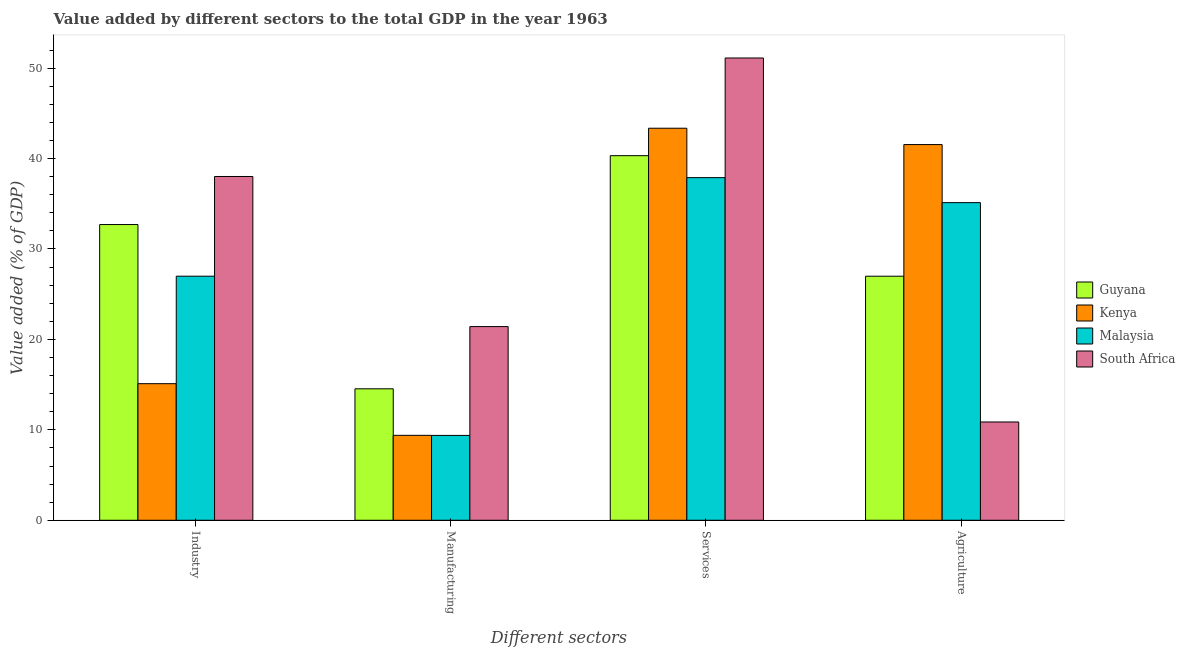Are the number of bars on each tick of the X-axis equal?
Offer a very short reply. Yes. How many bars are there on the 3rd tick from the left?
Your answer should be compact. 4. What is the label of the 3rd group of bars from the left?
Provide a short and direct response. Services. What is the value added by agricultural sector in Malaysia?
Your answer should be very brief. 35.12. Across all countries, what is the maximum value added by agricultural sector?
Your answer should be very brief. 41.54. Across all countries, what is the minimum value added by industrial sector?
Give a very brief answer. 15.1. In which country was the value added by manufacturing sector maximum?
Ensure brevity in your answer.  South Africa. In which country was the value added by agricultural sector minimum?
Your answer should be compact. South Africa. What is the total value added by agricultural sector in the graph?
Offer a very short reply. 114.52. What is the difference between the value added by industrial sector in Malaysia and that in South Africa?
Offer a very short reply. -11.02. What is the difference between the value added by manufacturing sector in Kenya and the value added by agricultural sector in South Africa?
Your answer should be very brief. -1.48. What is the average value added by manufacturing sector per country?
Your answer should be very brief. 13.68. What is the difference between the value added by industrial sector and value added by agricultural sector in Kenya?
Keep it short and to the point. -26.44. What is the ratio of the value added by industrial sector in South Africa to that in Kenya?
Provide a short and direct response. 2.52. Is the value added by manufacturing sector in Kenya less than that in Malaysia?
Offer a very short reply. No. Is the difference between the value added by industrial sector in Kenya and South Africa greater than the difference between the value added by manufacturing sector in Kenya and South Africa?
Provide a succinct answer. No. What is the difference between the highest and the second highest value added by agricultural sector?
Make the answer very short. 6.42. What is the difference between the highest and the lowest value added by services sector?
Offer a very short reply. 13.23. In how many countries, is the value added by manufacturing sector greater than the average value added by manufacturing sector taken over all countries?
Offer a very short reply. 2. Is it the case that in every country, the sum of the value added by services sector and value added by manufacturing sector is greater than the sum of value added by agricultural sector and value added by industrial sector?
Your answer should be compact. Yes. What does the 2nd bar from the left in Agriculture represents?
Provide a succinct answer. Kenya. What does the 2nd bar from the right in Manufacturing represents?
Give a very brief answer. Malaysia. Is it the case that in every country, the sum of the value added by industrial sector and value added by manufacturing sector is greater than the value added by services sector?
Your answer should be very brief. No. How many bars are there?
Keep it short and to the point. 16. What is the difference between two consecutive major ticks on the Y-axis?
Ensure brevity in your answer.  10. Are the values on the major ticks of Y-axis written in scientific E-notation?
Provide a short and direct response. No. Does the graph contain grids?
Provide a succinct answer. No. How many legend labels are there?
Offer a terse response. 4. How are the legend labels stacked?
Your answer should be compact. Vertical. What is the title of the graph?
Your answer should be very brief. Value added by different sectors to the total GDP in the year 1963. What is the label or title of the X-axis?
Ensure brevity in your answer.  Different sectors. What is the label or title of the Y-axis?
Your answer should be compact. Value added (% of GDP). What is the Value added (% of GDP) of Guyana in Industry?
Your answer should be compact. 32.7. What is the Value added (% of GDP) of Kenya in Industry?
Give a very brief answer. 15.1. What is the Value added (% of GDP) in Malaysia in Industry?
Offer a terse response. 26.99. What is the Value added (% of GDP) in South Africa in Industry?
Provide a short and direct response. 38.01. What is the Value added (% of GDP) of Guyana in Manufacturing?
Make the answer very short. 14.54. What is the Value added (% of GDP) in Kenya in Manufacturing?
Offer a terse response. 9.39. What is the Value added (% of GDP) in Malaysia in Manufacturing?
Your response must be concise. 9.38. What is the Value added (% of GDP) of South Africa in Manufacturing?
Provide a succinct answer. 21.42. What is the Value added (% of GDP) of Guyana in Services?
Provide a succinct answer. 40.31. What is the Value added (% of GDP) in Kenya in Services?
Make the answer very short. 43.35. What is the Value added (% of GDP) in Malaysia in Services?
Your response must be concise. 37.89. What is the Value added (% of GDP) in South Africa in Services?
Ensure brevity in your answer.  51.12. What is the Value added (% of GDP) of Guyana in Agriculture?
Your answer should be very brief. 26.99. What is the Value added (% of GDP) in Kenya in Agriculture?
Provide a succinct answer. 41.54. What is the Value added (% of GDP) of Malaysia in Agriculture?
Keep it short and to the point. 35.12. What is the Value added (% of GDP) of South Africa in Agriculture?
Your answer should be compact. 10.87. Across all Different sectors, what is the maximum Value added (% of GDP) in Guyana?
Offer a terse response. 40.31. Across all Different sectors, what is the maximum Value added (% of GDP) of Kenya?
Provide a short and direct response. 43.35. Across all Different sectors, what is the maximum Value added (% of GDP) in Malaysia?
Make the answer very short. 37.89. Across all Different sectors, what is the maximum Value added (% of GDP) of South Africa?
Make the answer very short. 51.12. Across all Different sectors, what is the minimum Value added (% of GDP) of Guyana?
Your answer should be very brief. 14.54. Across all Different sectors, what is the minimum Value added (% of GDP) of Kenya?
Make the answer very short. 9.39. Across all Different sectors, what is the minimum Value added (% of GDP) in Malaysia?
Your response must be concise. 9.38. Across all Different sectors, what is the minimum Value added (% of GDP) of South Africa?
Make the answer very short. 10.87. What is the total Value added (% of GDP) in Guyana in the graph?
Make the answer very short. 114.54. What is the total Value added (% of GDP) of Kenya in the graph?
Your answer should be very brief. 109.39. What is the total Value added (% of GDP) in Malaysia in the graph?
Your response must be concise. 109.38. What is the total Value added (% of GDP) in South Africa in the graph?
Offer a very short reply. 121.42. What is the difference between the Value added (% of GDP) in Guyana in Industry and that in Manufacturing?
Give a very brief answer. 18.16. What is the difference between the Value added (% of GDP) in Kenya in Industry and that in Manufacturing?
Keep it short and to the point. 5.71. What is the difference between the Value added (% of GDP) in Malaysia in Industry and that in Manufacturing?
Your answer should be compact. 17.61. What is the difference between the Value added (% of GDP) of South Africa in Industry and that in Manufacturing?
Provide a succinct answer. 16.6. What is the difference between the Value added (% of GDP) in Guyana in Industry and that in Services?
Your answer should be compact. -7.62. What is the difference between the Value added (% of GDP) in Kenya in Industry and that in Services?
Give a very brief answer. -28.25. What is the difference between the Value added (% of GDP) in Malaysia in Industry and that in Services?
Provide a short and direct response. -10.9. What is the difference between the Value added (% of GDP) in South Africa in Industry and that in Services?
Give a very brief answer. -13.1. What is the difference between the Value added (% of GDP) in Guyana in Industry and that in Agriculture?
Ensure brevity in your answer.  5.71. What is the difference between the Value added (% of GDP) in Kenya in Industry and that in Agriculture?
Give a very brief answer. -26.44. What is the difference between the Value added (% of GDP) in Malaysia in Industry and that in Agriculture?
Offer a very short reply. -8.13. What is the difference between the Value added (% of GDP) of South Africa in Industry and that in Agriculture?
Ensure brevity in your answer.  27.14. What is the difference between the Value added (% of GDP) in Guyana in Manufacturing and that in Services?
Provide a succinct answer. -25.78. What is the difference between the Value added (% of GDP) in Kenya in Manufacturing and that in Services?
Provide a succinct answer. -33.96. What is the difference between the Value added (% of GDP) of Malaysia in Manufacturing and that in Services?
Your answer should be very brief. -28.5. What is the difference between the Value added (% of GDP) of South Africa in Manufacturing and that in Services?
Offer a terse response. -29.7. What is the difference between the Value added (% of GDP) in Guyana in Manufacturing and that in Agriculture?
Ensure brevity in your answer.  -12.45. What is the difference between the Value added (% of GDP) of Kenya in Manufacturing and that in Agriculture?
Your answer should be compact. -32.15. What is the difference between the Value added (% of GDP) in Malaysia in Manufacturing and that in Agriculture?
Keep it short and to the point. -25.74. What is the difference between the Value added (% of GDP) of South Africa in Manufacturing and that in Agriculture?
Give a very brief answer. 10.55. What is the difference between the Value added (% of GDP) of Guyana in Services and that in Agriculture?
Provide a succinct answer. 13.33. What is the difference between the Value added (% of GDP) in Kenya in Services and that in Agriculture?
Give a very brief answer. 1.81. What is the difference between the Value added (% of GDP) in Malaysia in Services and that in Agriculture?
Provide a succinct answer. 2.76. What is the difference between the Value added (% of GDP) of South Africa in Services and that in Agriculture?
Make the answer very short. 40.25. What is the difference between the Value added (% of GDP) of Guyana in Industry and the Value added (% of GDP) of Kenya in Manufacturing?
Make the answer very short. 23.31. What is the difference between the Value added (% of GDP) of Guyana in Industry and the Value added (% of GDP) of Malaysia in Manufacturing?
Provide a short and direct response. 23.32. What is the difference between the Value added (% of GDP) in Guyana in Industry and the Value added (% of GDP) in South Africa in Manufacturing?
Keep it short and to the point. 11.28. What is the difference between the Value added (% of GDP) in Kenya in Industry and the Value added (% of GDP) in Malaysia in Manufacturing?
Keep it short and to the point. 5.72. What is the difference between the Value added (% of GDP) in Kenya in Industry and the Value added (% of GDP) in South Africa in Manufacturing?
Your answer should be compact. -6.31. What is the difference between the Value added (% of GDP) of Malaysia in Industry and the Value added (% of GDP) of South Africa in Manufacturing?
Your response must be concise. 5.57. What is the difference between the Value added (% of GDP) of Guyana in Industry and the Value added (% of GDP) of Kenya in Services?
Offer a terse response. -10.65. What is the difference between the Value added (% of GDP) in Guyana in Industry and the Value added (% of GDP) in Malaysia in Services?
Ensure brevity in your answer.  -5.19. What is the difference between the Value added (% of GDP) in Guyana in Industry and the Value added (% of GDP) in South Africa in Services?
Your answer should be very brief. -18.42. What is the difference between the Value added (% of GDP) in Kenya in Industry and the Value added (% of GDP) in Malaysia in Services?
Your answer should be compact. -22.78. What is the difference between the Value added (% of GDP) of Kenya in Industry and the Value added (% of GDP) of South Africa in Services?
Offer a terse response. -36.01. What is the difference between the Value added (% of GDP) of Malaysia in Industry and the Value added (% of GDP) of South Africa in Services?
Provide a short and direct response. -24.13. What is the difference between the Value added (% of GDP) of Guyana in Industry and the Value added (% of GDP) of Kenya in Agriculture?
Your response must be concise. -8.85. What is the difference between the Value added (% of GDP) of Guyana in Industry and the Value added (% of GDP) of Malaysia in Agriculture?
Give a very brief answer. -2.42. What is the difference between the Value added (% of GDP) of Guyana in Industry and the Value added (% of GDP) of South Africa in Agriculture?
Your answer should be very brief. 21.83. What is the difference between the Value added (% of GDP) of Kenya in Industry and the Value added (% of GDP) of Malaysia in Agriculture?
Give a very brief answer. -20.02. What is the difference between the Value added (% of GDP) of Kenya in Industry and the Value added (% of GDP) of South Africa in Agriculture?
Offer a very short reply. 4.24. What is the difference between the Value added (% of GDP) of Malaysia in Industry and the Value added (% of GDP) of South Africa in Agriculture?
Offer a very short reply. 16.12. What is the difference between the Value added (% of GDP) in Guyana in Manufacturing and the Value added (% of GDP) in Kenya in Services?
Offer a very short reply. -28.81. What is the difference between the Value added (% of GDP) in Guyana in Manufacturing and the Value added (% of GDP) in Malaysia in Services?
Keep it short and to the point. -23.35. What is the difference between the Value added (% of GDP) in Guyana in Manufacturing and the Value added (% of GDP) in South Africa in Services?
Give a very brief answer. -36.58. What is the difference between the Value added (% of GDP) in Kenya in Manufacturing and the Value added (% of GDP) in Malaysia in Services?
Your answer should be very brief. -28.5. What is the difference between the Value added (% of GDP) of Kenya in Manufacturing and the Value added (% of GDP) of South Africa in Services?
Provide a succinct answer. -41.73. What is the difference between the Value added (% of GDP) of Malaysia in Manufacturing and the Value added (% of GDP) of South Africa in Services?
Provide a short and direct response. -41.73. What is the difference between the Value added (% of GDP) in Guyana in Manufacturing and the Value added (% of GDP) in Kenya in Agriculture?
Keep it short and to the point. -27.01. What is the difference between the Value added (% of GDP) in Guyana in Manufacturing and the Value added (% of GDP) in Malaysia in Agriculture?
Your answer should be compact. -20.59. What is the difference between the Value added (% of GDP) of Guyana in Manufacturing and the Value added (% of GDP) of South Africa in Agriculture?
Provide a succinct answer. 3.67. What is the difference between the Value added (% of GDP) in Kenya in Manufacturing and the Value added (% of GDP) in Malaysia in Agriculture?
Your response must be concise. -25.73. What is the difference between the Value added (% of GDP) in Kenya in Manufacturing and the Value added (% of GDP) in South Africa in Agriculture?
Provide a succinct answer. -1.48. What is the difference between the Value added (% of GDP) of Malaysia in Manufacturing and the Value added (% of GDP) of South Africa in Agriculture?
Give a very brief answer. -1.49. What is the difference between the Value added (% of GDP) of Guyana in Services and the Value added (% of GDP) of Kenya in Agriculture?
Provide a short and direct response. -1.23. What is the difference between the Value added (% of GDP) of Guyana in Services and the Value added (% of GDP) of Malaysia in Agriculture?
Provide a succinct answer. 5.19. What is the difference between the Value added (% of GDP) in Guyana in Services and the Value added (% of GDP) in South Africa in Agriculture?
Make the answer very short. 29.45. What is the difference between the Value added (% of GDP) in Kenya in Services and the Value added (% of GDP) in Malaysia in Agriculture?
Provide a succinct answer. 8.23. What is the difference between the Value added (% of GDP) of Kenya in Services and the Value added (% of GDP) of South Africa in Agriculture?
Your answer should be very brief. 32.48. What is the difference between the Value added (% of GDP) of Malaysia in Services and the Value added (% of GDP) of South Africa in Agriculture?
Make the answer very short. 27.02. What is the average Value added (% of GDP) in Guyana per Different sectors?
Make the answer very short. 28.63. What is the average Value added (% of GDP) of Kenya per Different sectors?
Offer a terse response. 27.35. What is the average Value added (% of GDP) of Malaysia per Different sectors?
Provide a succinct answer. 27.35. What is the average Value added (% of GDP) of South Africa per Different sectors?
Ensure brevity in your answer.  30.35. What is the difference between the Value added (% of GDP) of Guyana and Value added (% of GDP) of Kenya in Industry?
Offer a terse response. 17.59. What is the difference between the Value added (% of GDP) of Guyana and Value added (% of GDP) of Malaysia in Industry?
Keep it short and to the point. 5.71. What is the difference between the Value added (% of GDP) of Guyana and Value added (% of GDP) of South Africa in Industry?
Your answer should be very brief. -5.31. What is the difference between the Value added (% of GDP) of Kenya and Value added (% of GDP) of Malaysia in Industry?
Ensure brevity in your answer.  -11.88. What is the difference between the Value added (% of GDP) of Kenya and Value added (% of GDP) of South Africa in Industry?
Offer a terse response. -22.91. What is the difference between the Value added (% of GDP) of Malaysia and Value added (% of GDP) of South Africa in Industry?
Keep it short and to the point. -11.02. What is the difference between the Value added (% of GDP) in Guyana and Value added (% of GDP) in Kenya in Manufacturing?
Offer a very short reply. 5.14. What is the difference between the Value added (% of GDP) in Guyana and Value added (% of GDP) in Malaysia in Manufacturing?
Make the answer very short. 5.15. What is the difference between the Value added (% of GDP) of Guyana and Value added (% of GDP) of South Africa in Manufacturing?
Your answer should be very brief. -6.88. What is the difference between the Value added (% of GDP) of Kenya and Value added (% of GDP) of Malaysia in Manufacturing?
Offer a very short reply. 0.01. What is the difference between the Value added (% of GDP) of Kenya and Value added (% of GDP) of South Africa in Manufacturing?
Keep it short and to the point. -12.02. What is the difference between the Value added (% of GDP) in Malaysia and Value added (% of GDP) in South Africa in Manufacturing?
Offer a very short reply. -12.03. What is the difference between the Value added (% of GDP) of Guyana and Value added (% of GDP) of Kenya in Services?
Provide a succinct answer. -3.04. What is the difference between the Value added (% of GDP) in Guyana and Value added (% of GDP) in Malaysia in Services?
Keep it short and to the point. 2.43. What is the difference between the Value added (% of GDP) in Guyana and Value added (% of GDP) in South Africa in Services?
Your answer should be compact. -10.8. What is the difference between the Value added (% of GDP) in Kenya and Value added (% of GDP) in Malaysia in Services?
Ensure brevity in your answer.  5.46. What is the difference between the Value added (% of GDP) of Kenya and Value added (% of GDP) of South Africa in Services?
Offer a very short reply. -7.77. What is the difference between the Value added (% of GDP) of Malaysia and Value added (% of GDP) of South Africa in Services?
Provide a succinct answer. -13.23. What is the difference between the Value added (% of GDP) of Guyana and Value added (% of GDP) of Kenya in Agriculture?
Your answer should be compact. -14.56. What is the difference between the Value added (% of GDP) of Guyana and Value added (% of GDP) of Malaysia in Agriculture?
Keep it short and to the point. -8.14. What is the difference between the Value added (% of GDP) in Guyana and Value added (% of GDP) in South Africa in Agriculture?
Offer a terse response. 16.12. What is the difference between the Value added (% of GDP) of Kenya and Value added (% of GDP) of Malaysia in Agriculture?
Offer a terse response. 6.42. What is the difference between the Value added (% of GDP) of Kenya and Value added (% of GDP) of South Africa in Agriculture?
Offer a very short reply. 30.68. What is the difference between the Value added (% of GDP) of Malaysia and Value added (% of GDP) of South Africa in Agriculture?
Provide a short and direct response. 24.25. What is the ratio of the Value added (% of GDP) of Guyana in Industry to that in Manufacturing?
Make the answer very short. 2.25. What is the ratio of the Value added (% of GDP) of Kenya in Industry to that in Manufacturing?
Your answer should be compact. 1.61. What is the ratio of the Value added (% of GDP) of Malaysia in Industry to that in Manufacturing?
Provide a short and direct response. 2.88. What is the ratio of the Value added (% of GDP) of South Africa in Industry to that in Manufacturing?
Your response must be concise. 1.77. What is the ratio of the Value added (% of GDP) in Guyana in Industry to that in Services?
Make the answer very short. 0.81. What is the ratio of the Value added (% of GDP) of Kenya in Industry to that in Services?
Give a very brief answer. 0.35. What is the ratio of the Value added (% of GDP) in Malaysia in Industry to that in Services?
Your answer should be very brief. 0.71. What is the ratio of the Value added (% of GDP) of South Africa in Industry to that in Services?
Your answer should be compact. 0.74. What is the ratio of the Value added (% of GDP) of Guyana in Industry to that in Agriculture?
Make the answer very short. 1.21. What is the ratio of the Value added (% of GDP) in Kenya in Industry to that in Agriculture?
Provide a short and direct response. 0.36. What is the ratio of the Value added (% of GDP) of Malaysia in Industry to that in Agriculture?
Offer a terse response. 0.77. What is the ratio of the Value added (% of GDP) of South Africa in Industry to that in Agriculture?
Your answer should be compact. 3.5. What is the ratio of the Value added (% of GDP) in Guyana in Manufacturing to that in Services?
Your answer should be compact. 0.36. What is the ratio of the Value added (% of GDP) in Kenya in Manufacturing to that in Services?
Provide a short and direct response. 0.22. What is the ratio of the Value added (% of GDP) of Malaysia in Manufacturing to that in Services?
Provide a succinct answer. 0.25. What is the ratio of the Value added (% of GDP) in South Africa in Manufacturing to that in Services?
Make the answer very short. 0.42. What is the ratio of the Value added (% of GDP) in Guyana in Manufacturing to that in Agriculture?
Your response must be concise. 0.54. What is the ratio of the Value added (% of GDP) in Kenya in Manufacturing to that in Agriculture?
Provide a short and direct response. 0.23. What is the ratio of the Value added (% of GDP) of Malaysia in Manufacturing to that in Agriculture?
Make the answer very short. 0.27. What is the ratio of the Value added (% of GDP) of South Africa in Manufacturing to that in Agriculture?
Provide a succinct answer. 1.97. What is the ratio of the Value added (% of GDP) of Guyana in Services to that in Agriculture?
Ensure brevity in your answer.  1.49. What is the ratio of the Value added (% of GDP) of Kenya in Services to that in Agriculture?
Ensure brevity in your answer.  1.04. What is the ratio of the Value added (% of GDP) of Malaysia in Services to that in Agriculture?
Your answer should be very brief. 1.08. What is the ratio of the Value added (% of GDP) in South Africa in Services to that in Agriculture?
Your answer should be very brief. 4.7. What is the difference between the highest and the second highest Value added (% of GDP) in Guyana?
Provide a succinct answer. 7.62. What is the difference between the highest and the second highest Value added (% of GDP) of Kenya?
Provide a succinct answer. 1.81. What is the difference between the highest and the second highest Value added (% of GDP) in Malaysia?
Your response must be concise. 2.76. What is the difference between the highest and the second highest Value added (% of GDP) in South Africa?
Make the answer very short. 13.1. What is the difference between the highest and the lowest Value added (% of GDP) of Guyana?
Offer a terse response. 25.78. What is the difference between the highest and the lowest Value added (% of GDP) in Kenya?
Make the answer very short. 33.96. What is the difference between the highest and the lowest Value added (% of GDP) in Malaysia?
Give a very brief answer. 28.5. What is the difference between the highest and the lowest Value added (% of GDP) in South Africa?
Your answer should be compact. 40.25. 